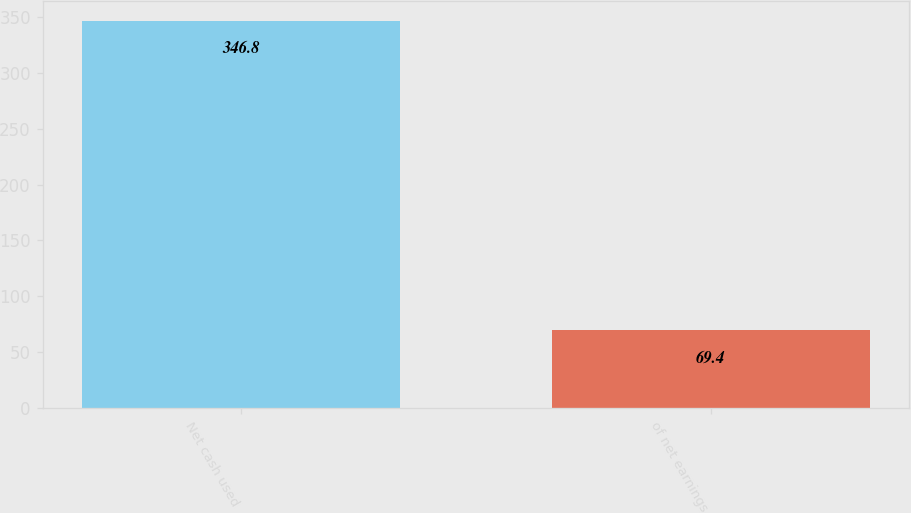Convert chart. <chart><loc_0><loc_0><loc_500><loc_500><bar_chart><fcel>Net cash used<fcel>of net earnings<nl><fcel>346.8<fcel>69.4<nl></chart> 